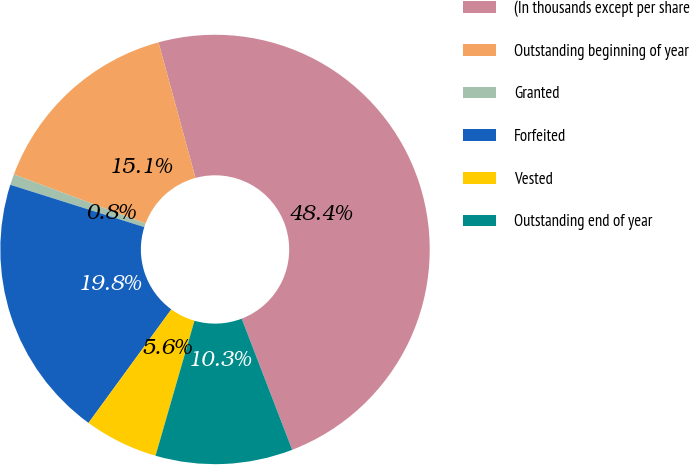<chart> <loc_0><loc_0><loc_500><loc_500><pie_chart><fcel>(In thousands except per share<fcel>Outstanding beginning of year<fcel>Granted<fcel>Forfeited<fcel>Vested<fcel>Outstanding end of year<nl><fcel>48.39%<fcel>15.08%<fcel>0.81%<fcel>19.84%<fcel>5.56%<fcel>10.32%<nl></chart> 